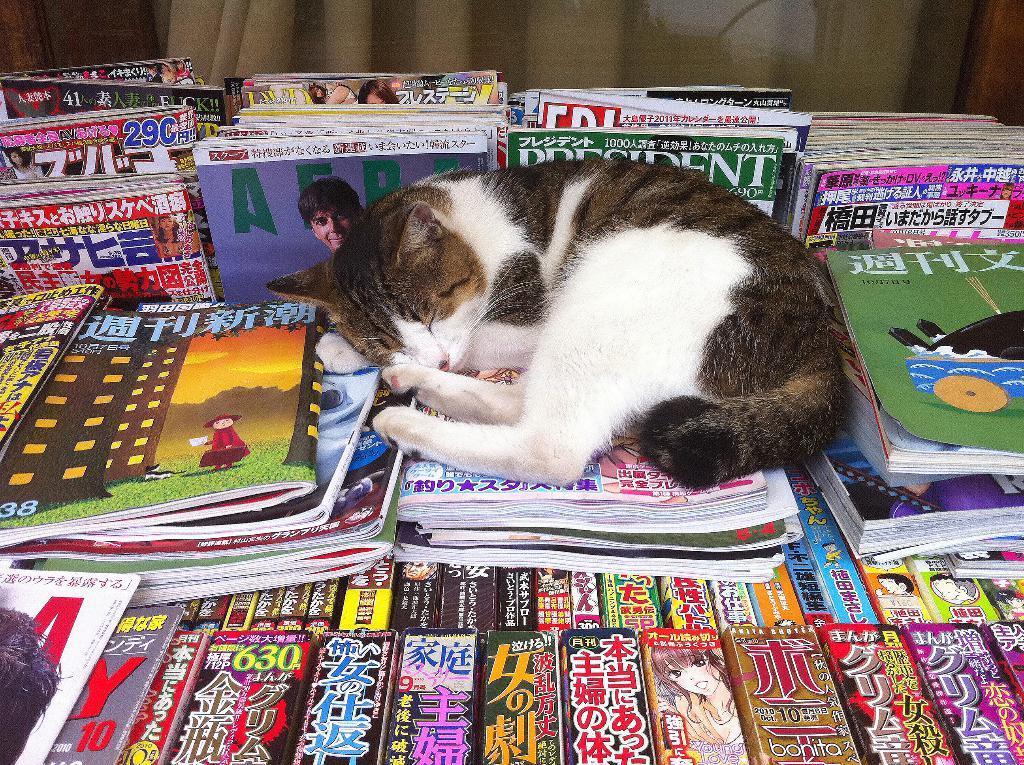Please provide a concise description of this image. In this image we can see a cat is sleeping on books. Behind cat so many books are arranged. 